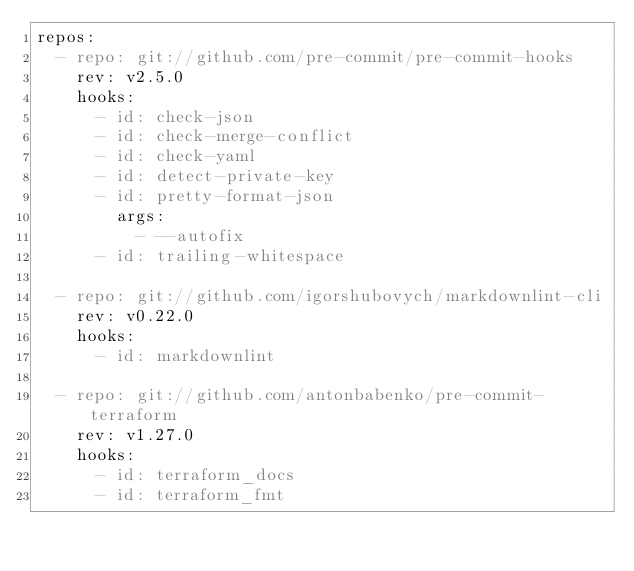Convert code to text. <code><loc_0><loc_0><loc_500><loc_500><_YAML_>repos:
  - repo: git://github.com/pre-commit/pre-commit-hooks
    rev: v2.5.0
    hooks:
      - id: check-json
      - id: check-merge-conflict
      - id: check-yaml
      - id: detect-private-key
      - id: pretty-format-json
        args:
          - --autofix
      - id: trailing-whitespace

  - repo: git://github.com/igorshubovych/markdownlint-cli
    rev: v0.22.0
    hooks:
      - id: markdownlint

  - repo: git://github.com/antonbabenko/pre-commit-terraform
    rev: v1.27.0
    hooks:
      - id: terraform_docs
      - id: terraform_fmt
</code> 